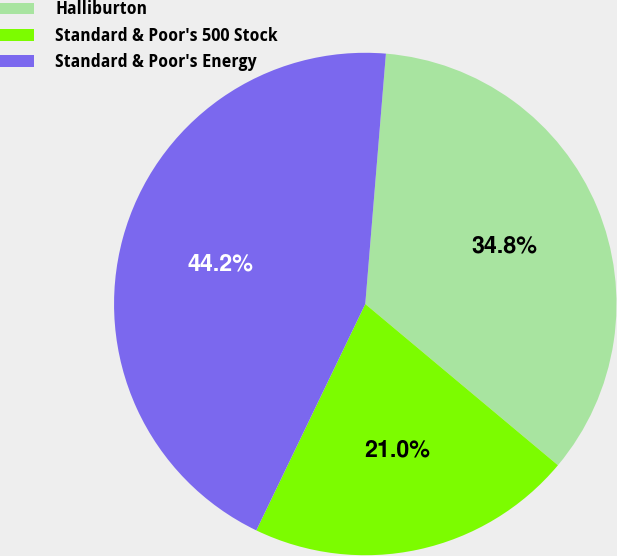<chart> <loc_0><loc_0><loc_500><loc_500><pie_chart><fcel>Halliburton<fcel>Standard & Poor's 500 Stock<fcel>Standard & Poor's Energy<nl><fcel>34.78%<fcel>21.05%<fcel>44.17%<nl></chart> 